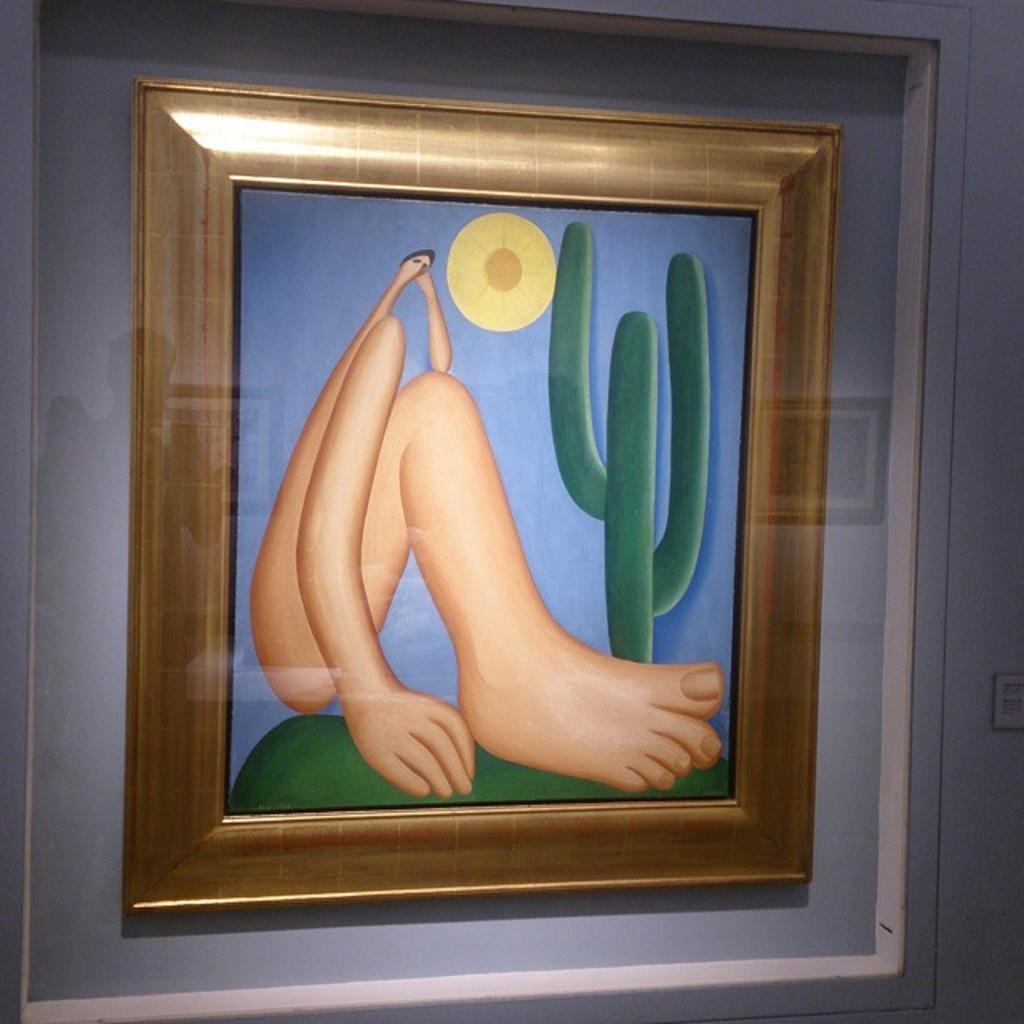What is the main object in the image? There is a frame in the image. What is depicted in the frame? The frame contains a painting of a leg and a plant. Where is the frame located in the image? The frame is attached to a wall. What channel is the painting of a leg in the image? There is no reference to a channel in the image. 